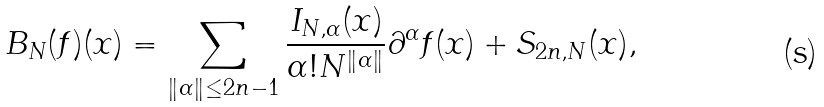<formula> <loc_0><loc_0><loc_500><loc_500>B _ { N } ( f ) ( x ) = \sum _ { \| \alpha \| \leq 2 n - 1 } \frac { I _ { N , \alpha } ( x ) } { \alpha ! N ^ { \| \alpha \| } } \partial ^ { \alpha } f ( x ) + S _ { 2 n , N } ( x ) ,</formula> 